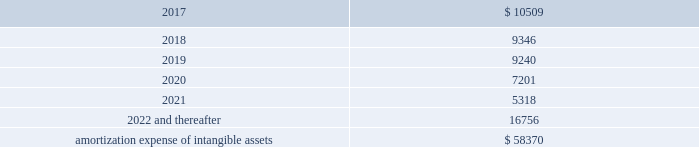Amortization expense , which is included in selling , general and administrative expenses , was $ 13.0 million , $ 13.9 million and $ 8.5 million for the years ended december 31 , 2016 , 2015 and 2014 , respectively .
The following is the estimated amortization expense for the company 2019s intangible assets as of december 31 , 2016 : ( in thousands ) .
At december 31 , 2016 , 2015 and 2014 , the company determined that its goodwill and indefinite- lived intangible assets were not impaired .
Credit facility and other long term debt credit facility the company is party to a credit agreement that provides revolving commitments for up to $ 1.25 billion of borrowings , as well as term loan commitments , in each case maturing in january 2021 .
As of december 31 , 2016 there was no outstanding balance under the revolving credit facility and $ 186.3 million of term loan borrowings remained outstanding .
At the company 2019s request and the lender 2019s consent , revolving and or term loan borrowings may be increased by up to $ 300.0 million in aggregate , subject to certain conditions as set forth in the credit agreement , as amended .
Incremental borrowings are uncommitted and the availability thereof , will depend on market conditions at the time the company seeks to incur such borrowings .
The borrowings under the revolving credit facility have maturities of less than one year .
Up to $ 50.0 million of the facility may be used for the issuance of letters of credit .
There were $ 2.6 million of letters of credit outstanding as of december 31 , 2016 .
The credit agreement contains negative covenants that , subject to significant exceptions , limit the ability of the company and its subsidiaries to , among other things , incur additional indebtedness , make restricted payments , pledge their assets as security , make investments , loans , advances , guarantees and acquisitions , undergo fundamental changes and enter into transactions with affiliates .
The company is also required to maintain a ratio of consolidated ebitda , as defined in the credit agreement , to consolidated interest expense of not less than 3.50 to 1.00 and is not permitted to allow the ratio of consolidated total indebtedness to consolidated ebitda to be greater than 3.25 to 1.00 ( 201cconsolidated leverage ratio 201d ) .
As of december 31 , 2016 , the company was in compliance with these ratios .
In addition , the credit agreement contains events of default that are customary for a facility of this nature , and includes a cross default provision whereby an event of default under other material indebtedness , as defined in the credit agreement , will be considered an event of default under the credit agreement .
Borrowings under the credit agreement bear interest at a rate per annum equal to , at the company 2019s option , either ( a ) an alternate base rate , or ( b ) a rate based on the rates applicable for deposits in the interbank market for u.s .
Dollars or the applicable currency in which the loans are made ( 201cadjusted libor 201d ) , plus in each case an applicable margin .
The applicable margin for loans will .
What was the difference in millions of amortization expense between 2015 and 2016? 
Computations: (13.0 - 13.9)
Answer: -0.9. 